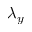Convert formula to latex. <formula><loc_0><loc_0><loc_500><loc_500>\lambda _ { y }</formula> 